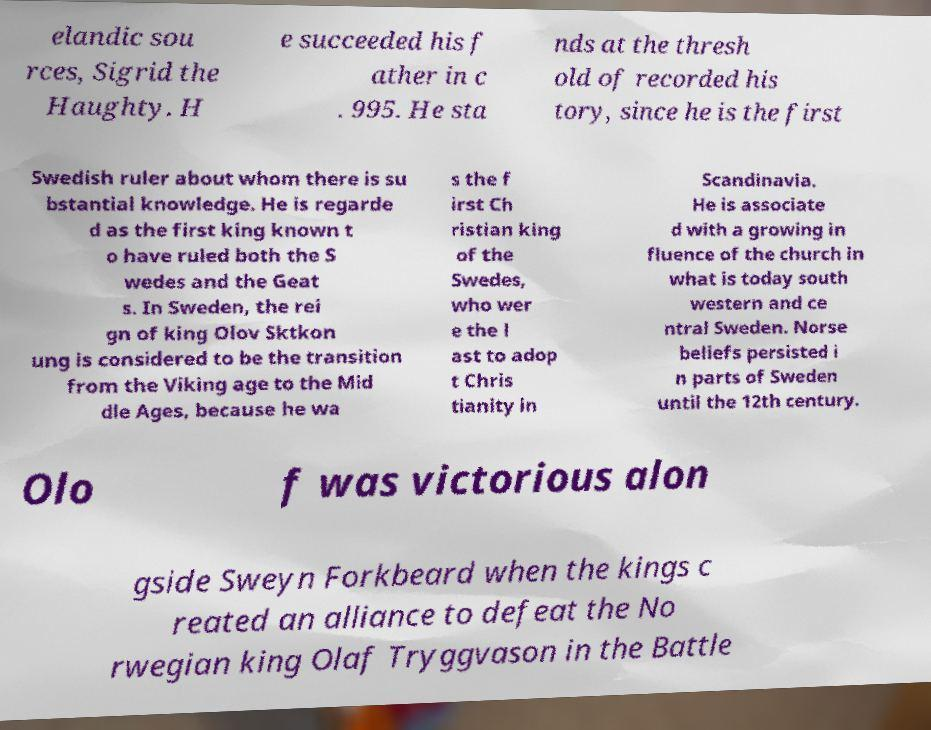For documentation purposes, I need the text within this image transcribed. Could you provide that? elandic sou rces, Sigrid the Haughty. H e succeeded his f ather in c . 995. He sta nds at the thresh old of recorded his tory, since he is the first Swedish ruler about whom there is su bstantial knowledge. He is regarde d as the first king known t o have ruled both the S wedes and the Geat s. In Sweden, the rei gn of king Olov Sktkon ung is considered to be the transition from the Viking age to the Mid dle Ages, because he wa s the f irst Ch ristian king of the Swedes, who wer e the l ast to adop t Chris tianity in Scandinavia. He is associate d with a growing in fluence of the church in what is today south western and ce ntral Sweden. Norse beliefs persisted i n parts of Sweden until the 12th century. Olo f was victorious alon gside Sweyn Forkbeard when the kings c reated an alliance to defeat the No rwegian king Olaf Tryggvason in the Battle 